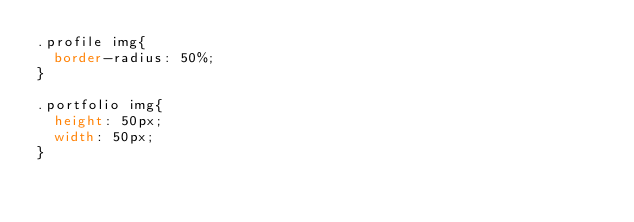Convert code to text. <code><loc_0><loc_0><loc_500><loc_500><_CSS_>.profile img{
  border-radius: 50%;
}

.portfolio img{
  height: 50px;
  width: 50px;
}
</code> 